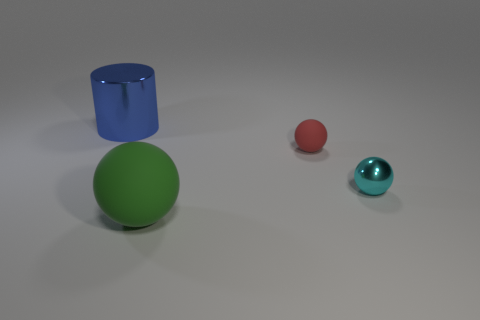Imagine these objects are part of a game. What could the rules be involving the different colors and shapes? In a hypothetical game involving these objects, we could assign points based on color and shape. For instance, green spheres might be worth 5 points, blue objects 3 points, and red objects 2 points. Players could 'collect' these objects in a virtual environment, aiming to accumulate the highest score. The challenge could involve obstacles or time constraints to add complexity. 